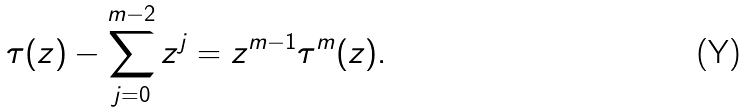Convert formula to latex. <formula><loc_0><loc_0><loc_500><loc_500>\tau ( z ) - \sum _ { j = 0 } ^ { m - 2 } z ^ { j } = z ^ { m - 1 } \tau ^ { m } ( z ) .</formula> 